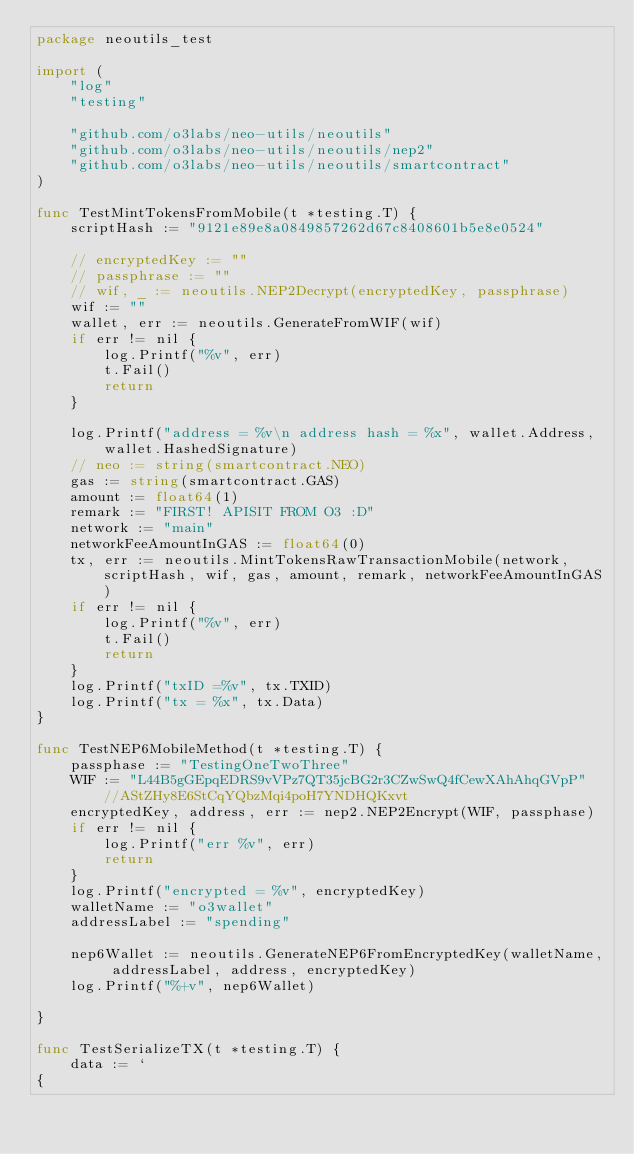Convert code to text. <code><loc_0><loc_0><loc_500><loc_500><_Go_>package neoutils_test

import (
	"log"
	"testing"

	"github.com/o3labs/neo-utils/neoutils"
	"github.com/o3labs/neo-utils/neoutils/nep2"
	"github.com/o3labs/neo-utils/neoutils/smartcontract"
)

func TestMintTokensFromMobile(t *testing.T) {
	scriptHash := "9121e89e8a0849857262d67c8408601b5e8e0524"

	// encryptedKey := ""
	// passphrase := ""
	// wif, _ := neoutils.NEP2Decrypt(encryptedKey, passphrase)
	wif := ""
	wallet, err := neoutils.GenerateFromWIF(wif)
	if err != nil {
		log.Printf("%v", err)
		t.Fail()
		return
	}

	log.Printf("address = %v\n address hash = %x", wallet.Address, wallet.HashedSignature)
	// neo := string(smartcontract.NEO)
	gas := string(smartcontract.GAS)
	amount := float64(1)
	remark := "FIRST! APISIT FROM O3 :D"
	network := "main"
	networkFeeAmountInGAS := float64(0)
	tx, err := neoutils.MintTokensRawTransactionMobile(network, scriptHash, wif, gas, amount, remark, networkFeeAmountInGAS)
	if err != nil {
		log.Printf("%v", err)
		t.Fail()
		return
	}
	log.Printf("txID =%v", tx.TXID)
	log.Printf("tx = %x", tx.Data)
}

func TestNEP6MobileMethod(t *testing.T) {
	passphase := "TestingOneTwoThree"
	WIF := "L44B5gGEpqEDRS9vVPz7QT35jcBG2r3CZwSwQ4fCewXAhAhqGVpP" //AStZHy8E6StCqYQbzMqi4poH7YNDHQKxvt
	encryptedKey, address, err := nep2.NEP2Encrypt(WIF, passphase)
	if err != nil {
		log.Printf("err %v", err)
		return
	}
	log.Printf("encrypted = %v", encryptedKey)
	walletName := "o3wallet"
	addressLabel := "spending"

	nep6Wallet := neoutils.GenerateNEP6FromEncryptedKey(walletName, addressLabel, address, encryptedKey)
	log.Printf("%+v", nep6Wallet)

}

func TestSerializeTX(t *testing.T) {
	data := `
{</code> 